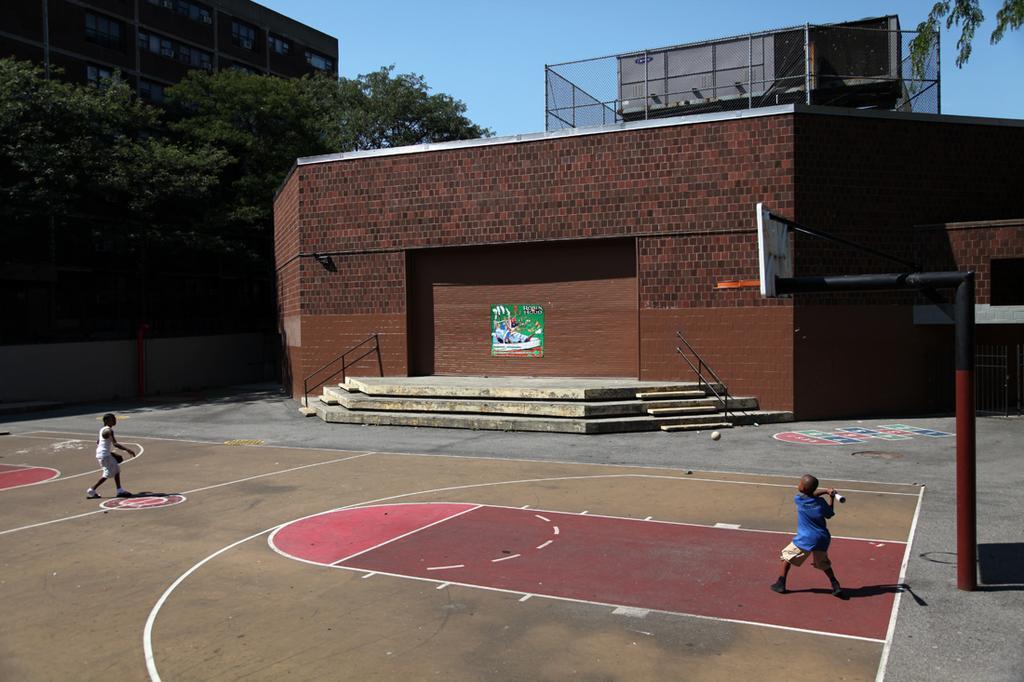Could you give a brief overview of what you see in this image? This image consists of a basketball court. In which there are two person. In the background, there is a wall. To the left, there are trees along with the building. 